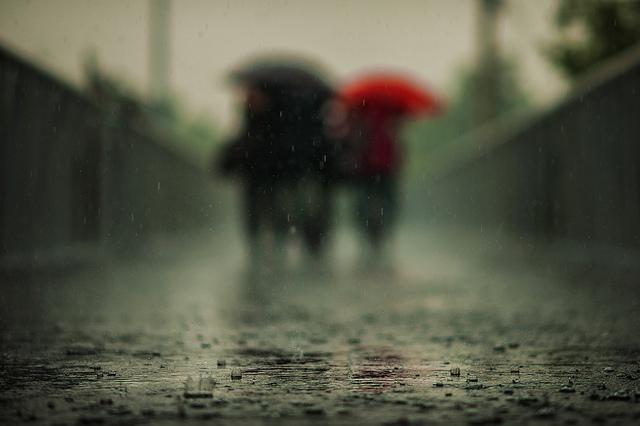Can you tell how many umbrellas there are?
Keep it brief. 2. Is this in focus?
Answer briefly. No. Is it raining?
Concise answer only. Yes. 